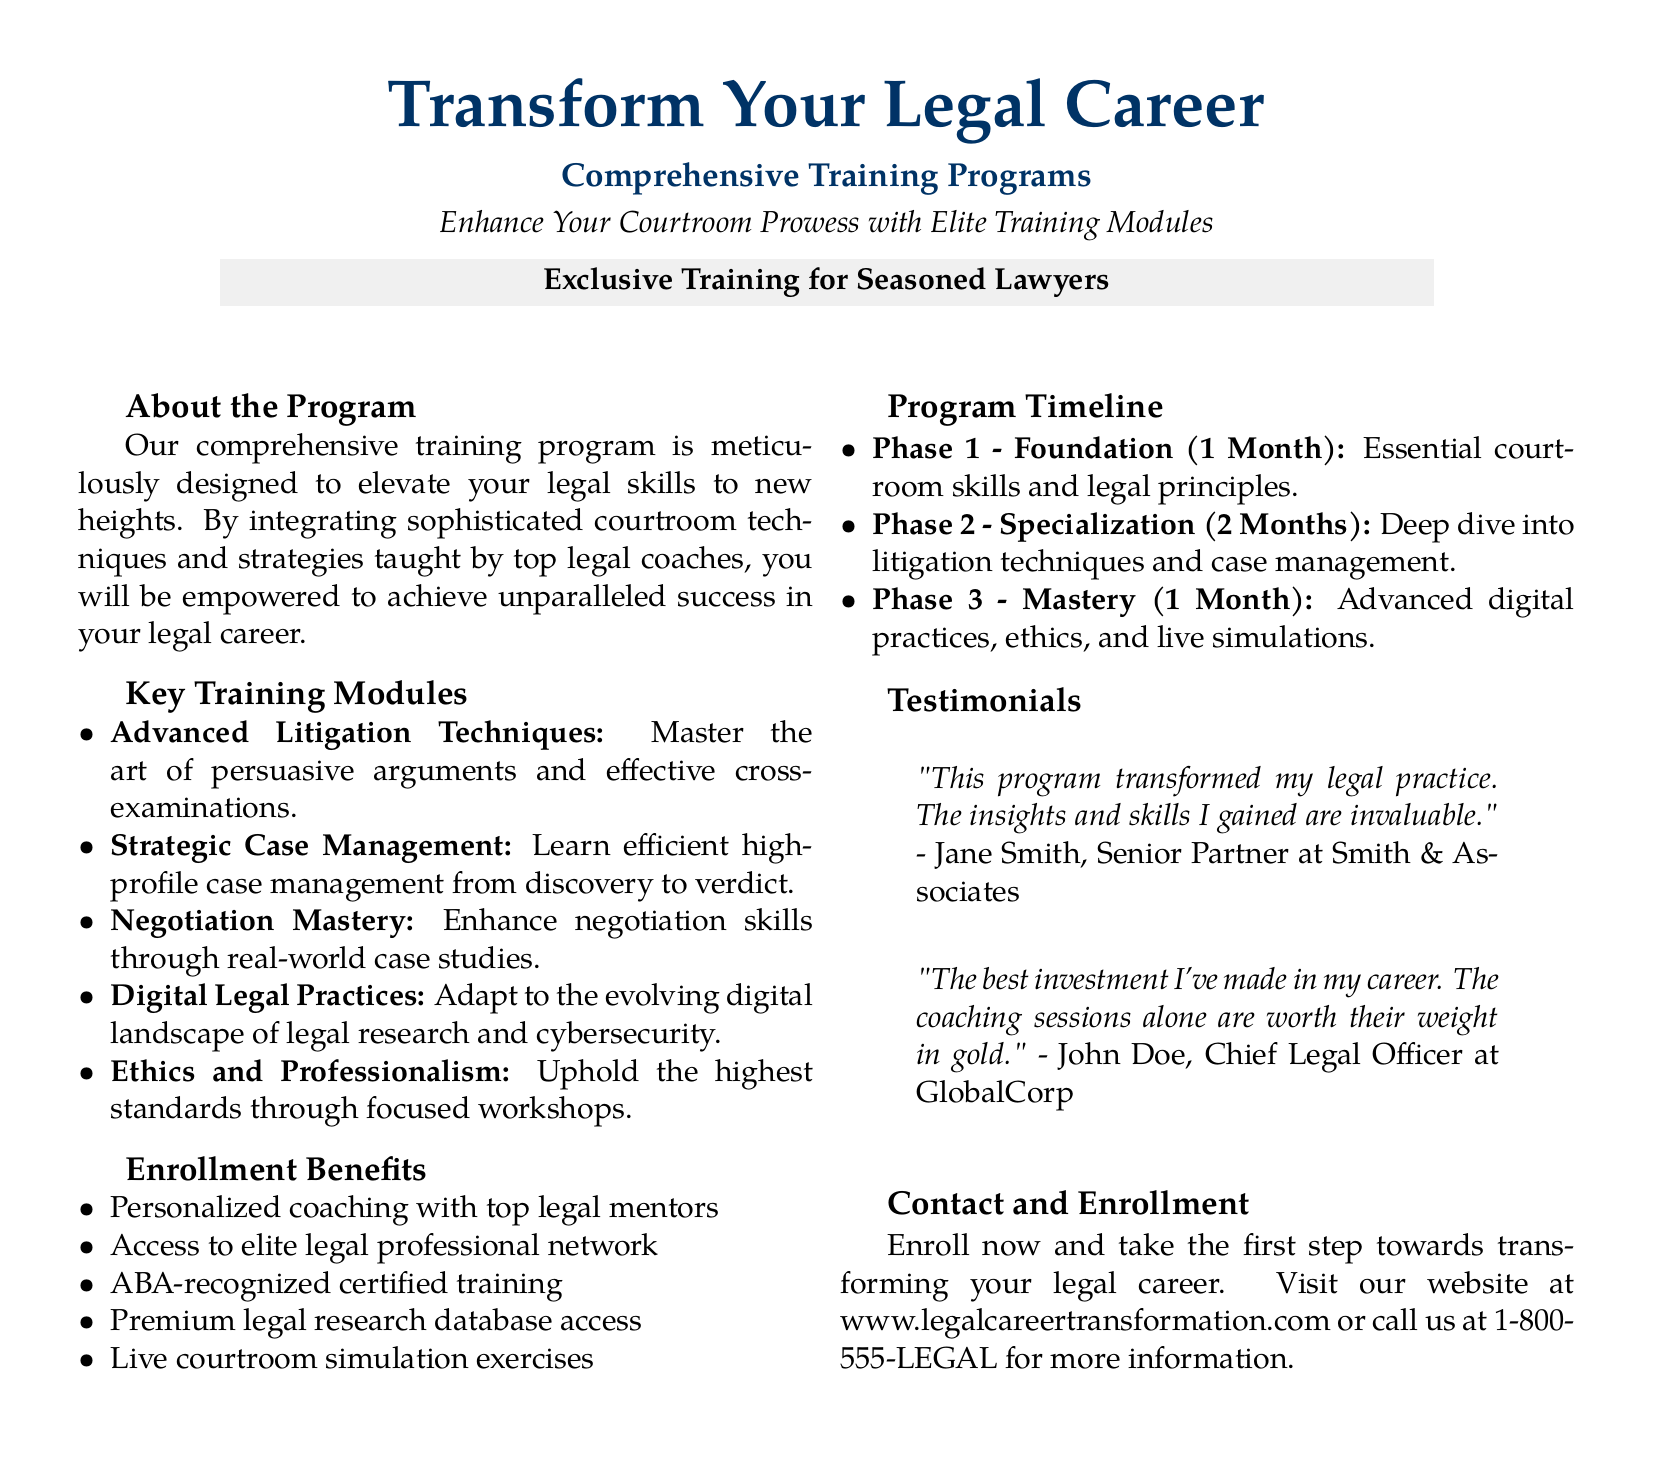What is the title of the program? The title of the program is prominently displayed at the top of the document, indicating its primary focus.
Answer: Transform Your Legal Career What is a key training module offered? The document lists various training modules, one of which is specifically mentioned as a key focus area.
Answer: Advanced Litigation Techniques How long is the Foundation phase of the program? The timeline section provides specific durations for each phase of the program.
Answer: 1 Month What is one benefit of enrollment? The document outlines several benefits of enrollment, highlighting unique opportunities provided to participants.
Answer: Personalized coaching Who is a testimonial by? The testimonials section includes quotes from individuals who have participated in the program, providing credibility and feedback.
Answer: Jane Smith How many phases are there in the program? The program timeline section details the structure of the training, indicating how it is divided.
Answer: 3 What type of professionals is the program aimed at? The introduction section clarifies the target audience for the training program.
Answer: Seasoned Lawyers What is a feature of the Mastery phase? The document describes what is included in the final phase of the program, indicating an area of focus.
Answer: Live simulations 